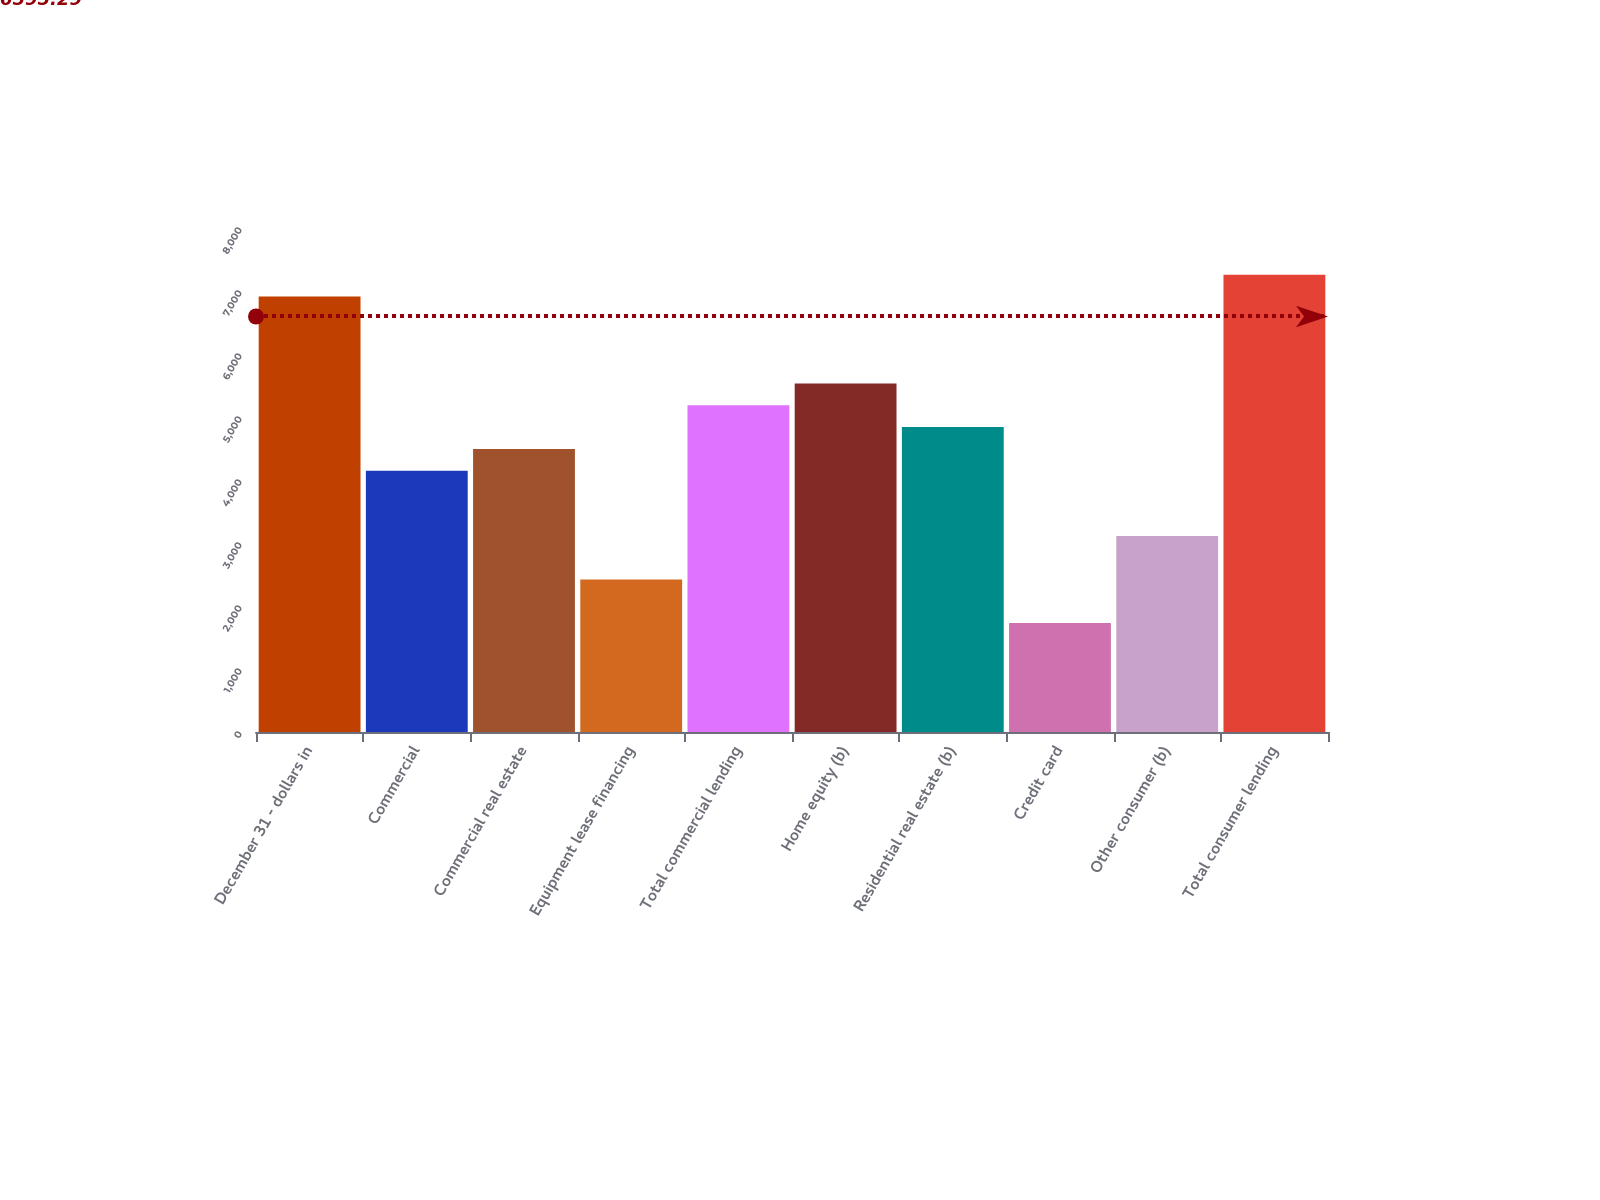<chart> <loc_0><loc_0><loc_500><loc_500><bar_chart><fcel>December 31 - dollars in<fcel>Commercial<fcel>Commercial real estate<fcel>Equipment lease financing<fcel>Total commercial lending<fcel>Home equity (b)<fcel>Residential real estate (b)<fcel>Credit card<fcel>Other consumer (b)<fcel>Total consumer lending<nl><fcel>6913.78<fcel>4148.34<fcel>4494.02<fcel>2419.94<fcel>5185.38<fcel>5531.06<fcel>4839.7<fcel>1728.58<fcel>3111.3<fcel>7259.46<nl></chart> 